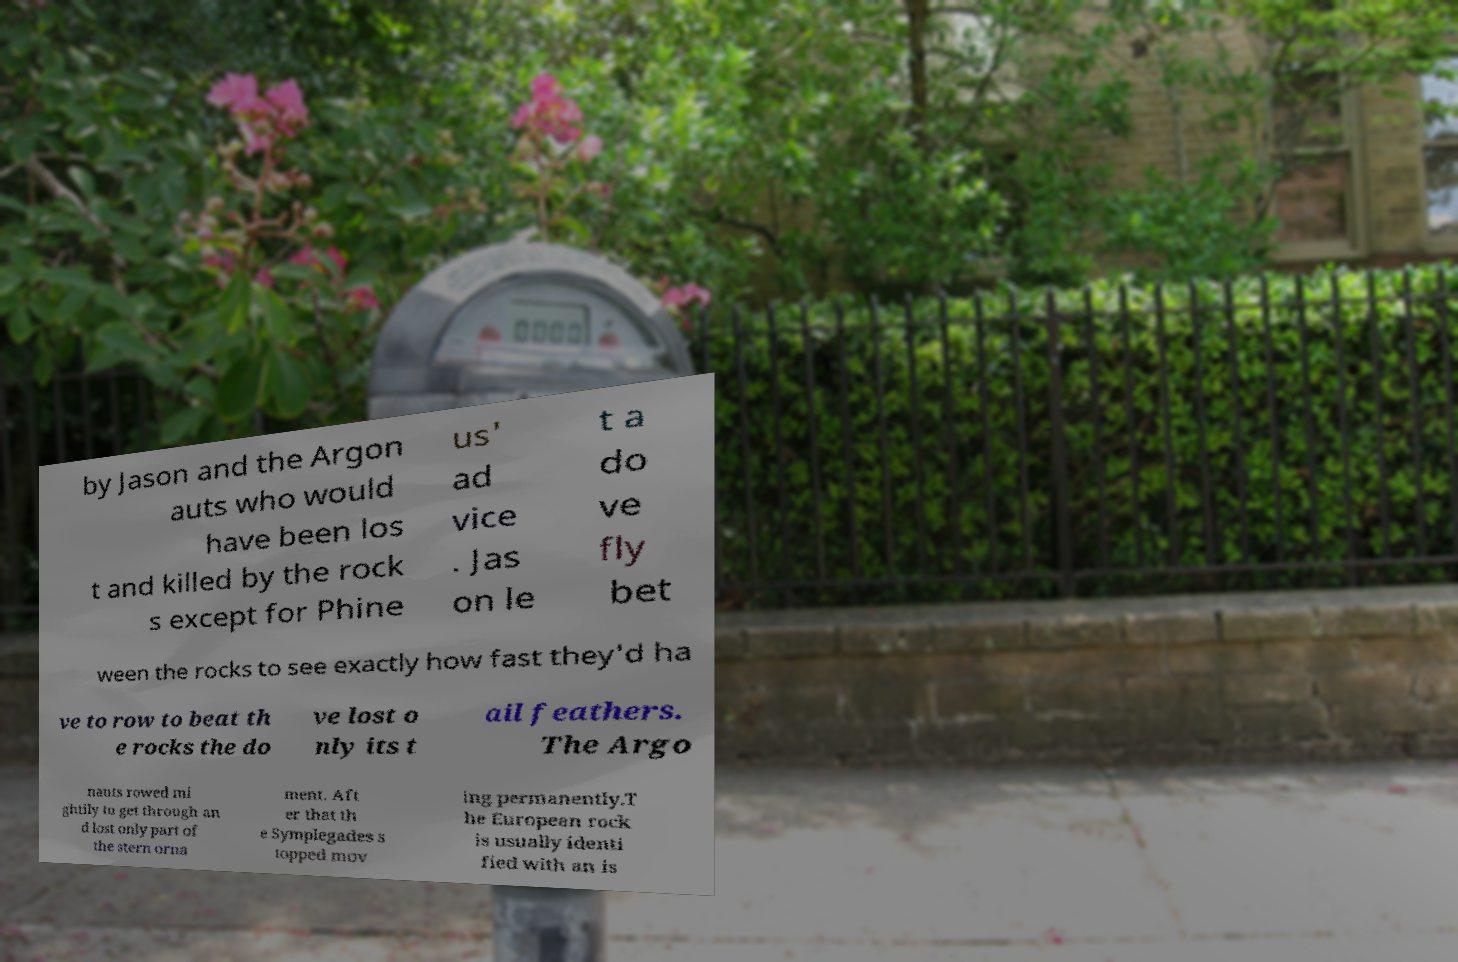Could you assist in decoding the text presented in this image and type it out clearly? by Jason and the Argon auts who would have been los t and killed by the rock s except for Phine us' ad vice . Jas on le t a do ve fly bet ween the rocks to see exactly how fast they'd ha ve to row to beat th e rocks the do ve lost o nly its t ail feathers. The Argo nauts rowed mi ghtily to get through an d lost only part of the stern orna ment. Aft er that th e Symplegades s topped mov ing permanently.T he European rock is usually identi fied with an is 